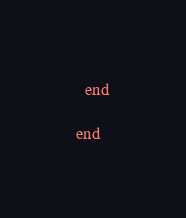Convert code to text. <code><loc_0><loc_0><loc_500><loc_500><_Ruby_>  end
  
end</code> 